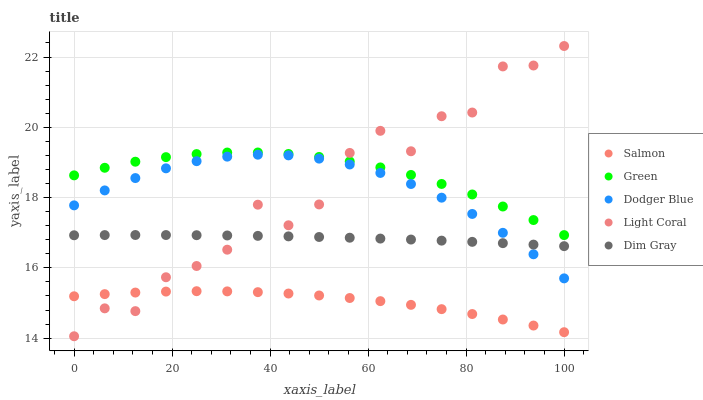Does Salmon have the minimum area under the curve?
Answer yes or no. Yes. Does Green have the maximum area under the curve?
Answer yes or no. Yes. Does Dim Gray have the minimum area under the curve?
Answer yes or no. No. Does Dim Gray have the maximum area under the curve?
Answer yes or no. No. Is Dim Gray the smoothest?
Answer yes or no. Yes. Is Light Coral the roughest?
Answer yes or no. Yes. Is Green the smoothest?
Answer yes or no. No. Is Green the roughest?
Answer yes or no. No. Does Light Coral have the lowest value?
Answer yes or no. Yes. Does Dim Gray have the lowest value?
Answer yes or no. No. Does Light Coral have the highest value?
Answer yes or no. Yes. Does Green have the highest value?
Answer yes or no. No. Is Dodger Blue less than Green?
Answer yes or no. Yes. Is Green greater than Salmon?
Answer yes or no. Yes. Does Dim Gray intersect Dodger Blue?
Answer yes or no. Yes. Is Dim Gray less than Dodger Blue?
Answer yes or no. No. Is Dim Gray greater than Dodger Blue?
Answer yes or no. No. Does Dodger Blue intersect Green?
Answer yes or no. No. 